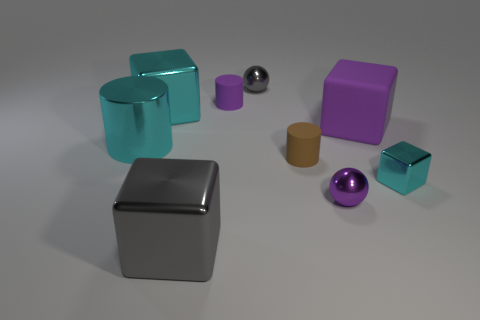Are there fewer tiny cyan shiny things in front of the gray cube than tiny brown objects left of the big cyan shiny block?
Give a very brief answer. No. How many gray spheres have the same material as the big gray object?
Your answer should be very brief. 1. There is a gray metal object that is behind the cyan object right of the purple metal object; is there a small brown thing left of it?
Offer a very short reply. No. How many cubes are brown matte objects or small gray objects?
Make the answer very short. 0. Do the big purple rubber object and the tiny purple thing left of the purple shiny object have the same shape?
Ensure brevity in your answer.  No. Is the number of big purple things that are behind the large rubber block less than the number of cyan balls?
Provide a short and direct response. No. Are there any cyan things behind the tiny purple rubber cylinder?
Your answer should be very brief. No. Are there any tiny brown objects of the same shape as the large gray thing?
Your answer should be very brief. No. What is the shape of the cyan shiny thing that is the same size as the purple metallic object?
Provide a short and direct response. Cube. How many things are either big shiny objects that are in front of the small cyan cube or big red metal cylinders?
Your response must be concise. 1. 